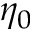<formula> <loc_0><loc_0><loc_500><loc_500>\eta _ { 0 }</formula> 